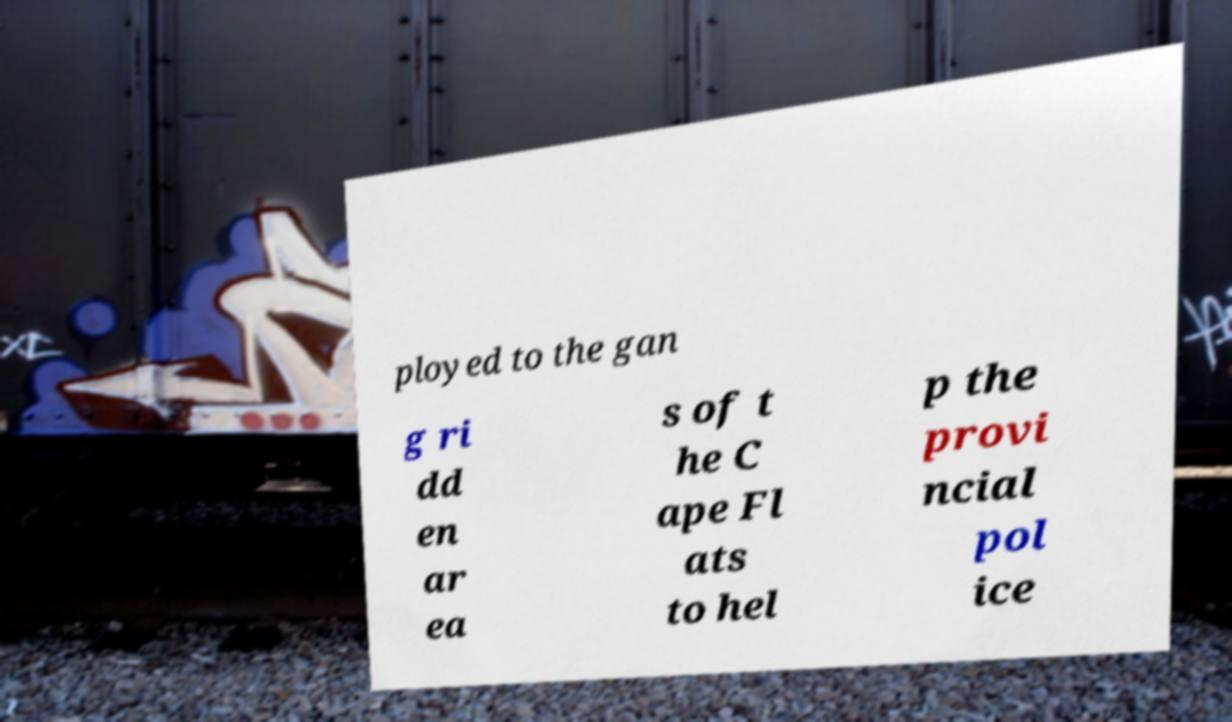Could you extract and type out the text from this image? ployed to the gan g ri dd en ar ea s of t he C ape Fl ats to hel p the provi ncial pol ice 